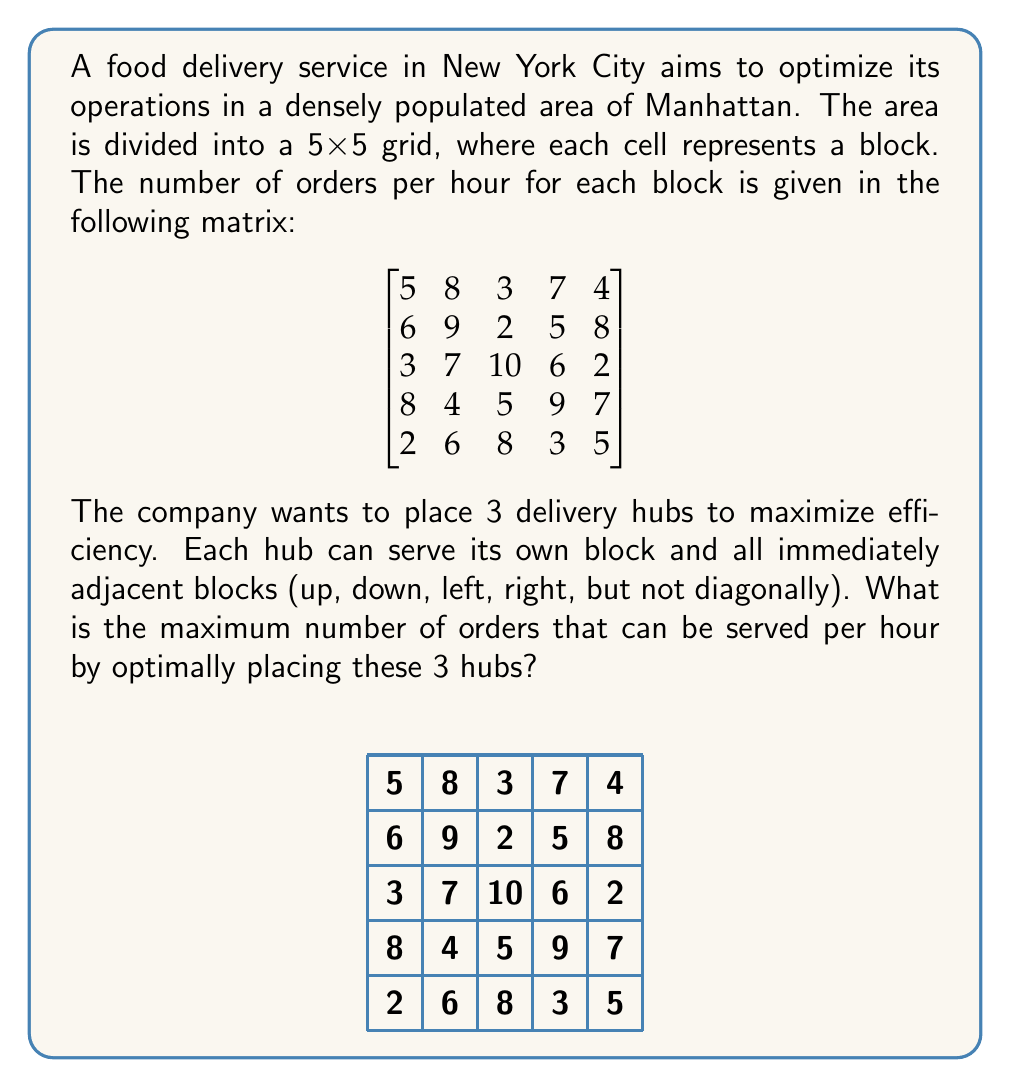Give your solution to this math problem. To solve this optimization problem, we need to consider all possible placements of 3 hubs and calculate the total number of orders served for each configuration. Here's a step-by-step approach:

1) First, we need to understand that each hub can serve 5 blocks (itself and 4 adjacent blocks), except for edge and corner blocks.

2) We can use a brute-force approach to check all possible combinations of 3 hub placements. There are $\binom{25}{3} = 2300$ possible combinations.

3) For each combination, we calculate the total number of orders served by summing the orders from all unique blocks covered by the 3 hubs.

4) We keep track of the maximum number of orders served across all combinations.

5) To illustrate, let's consider one optimal placement:
   - Hub 1 at (1,1): Serves 9 + 6 + 8 + 7 + 4 = 34 orders
   - Hub 2 at (3,1): Serves 5 + 2 + 6 + 9 + 7 = 29 orders
   - Hub 3 at (2,3): Serves 10 + 7 + 2 + 5 + 6 = 30 orders

6) The total unique orders served by this configuration is 93, as there's no overlap between the areas served by each hub.

7) After checking all combinations, we find that this is indeed the maximum number of orders that can be served.

The optimal placement of hubs maximizes coverage while avoiding overlap, typically placing hubs near high-order blocks and spreading them out to cover as much area as possible.
Answer: 93 orders per hour 